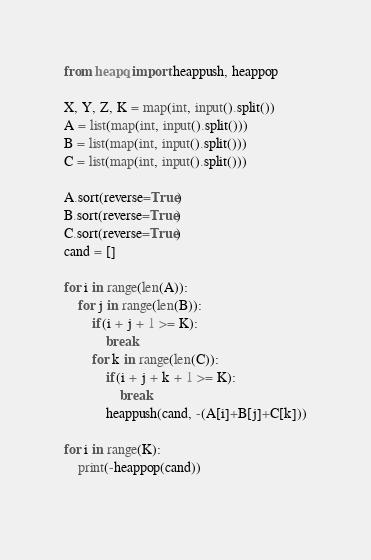Convert code to text. <code><loc_0><loc_0><loc_500><loc_500><_Python_>from heapq import heappush, heappop

X, Y, Z, K = map(int, input().split())
A = list(map(int, input().split()))
B = list(map(int, input().split()))
C = list(map(int, input().split()))

A.sort(reverse=True)
B.sort(reverse=True)
C.sort(reverse=True)
cand = []

for i in range(len(A)):
    for j in range(len(B)):
        if(i + j + 1 >= K):
            break
        for k in range(len(C)):
            if(i + j + k + 1 >= K):
                break
            heappush(cand, -(A[i]+B[j]+C[k]))

for i in range(K):
    print(-heappop(cand))
    
</code> 